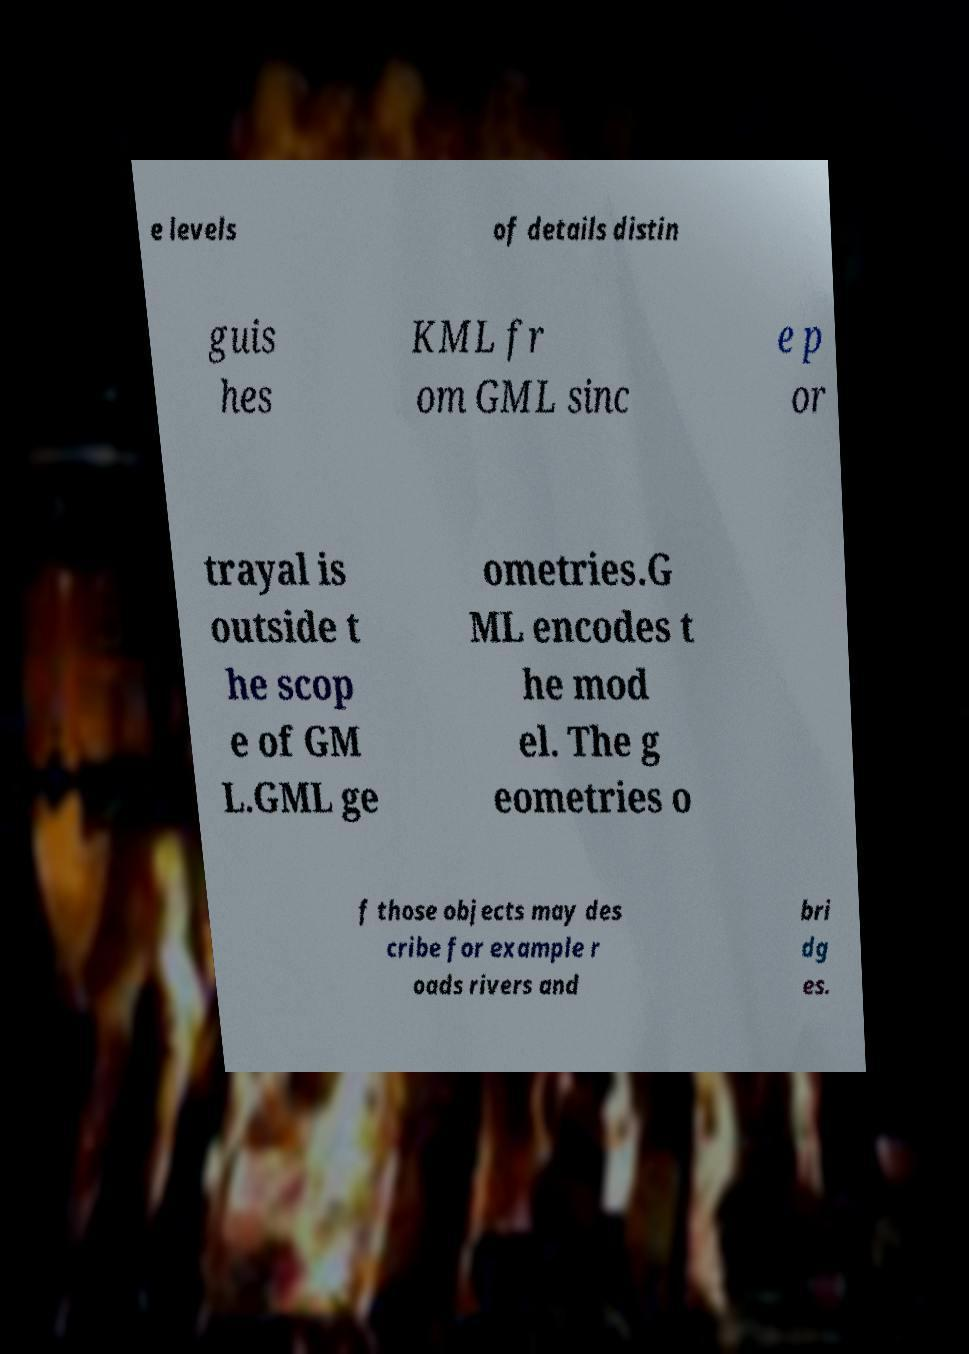Could you assist in decoding the text presented in this image and type it out clearly? e levels of details distin guis hes KML fr om GML sinc e p or trayal is outside t he scop e of GM L.GML ge ometries.G ML encodes t he mod el. The g eometries o f those objects may des cribe for example r oads rivers and bri dg es. 